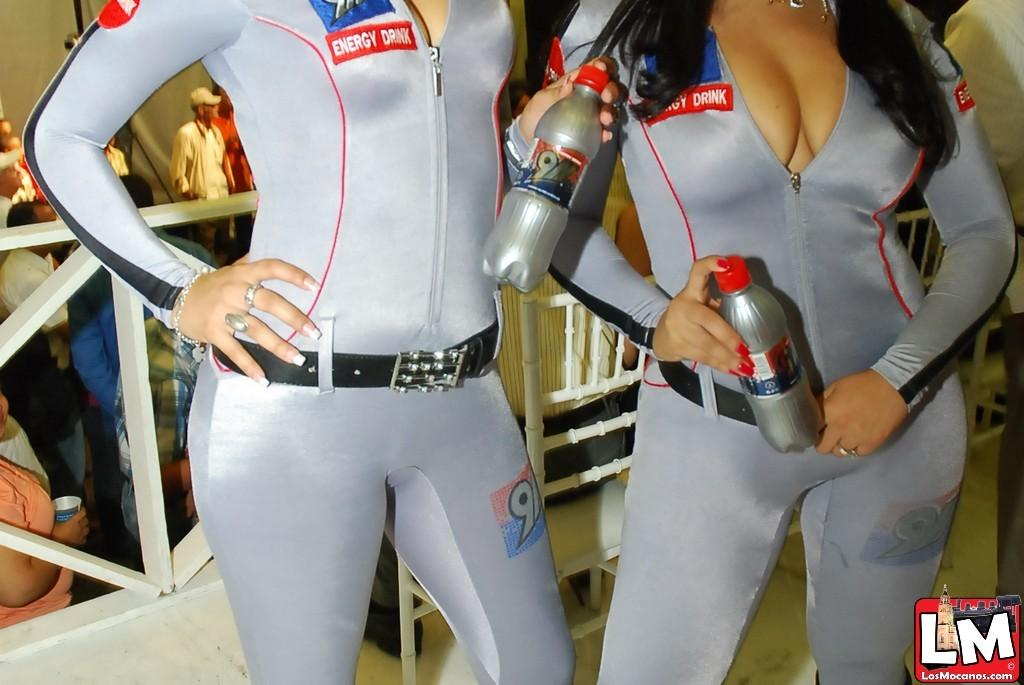<image>
Present a compact description of the photo's key features. Two women in tight silver bodysuits promote an energy drink at an event. 